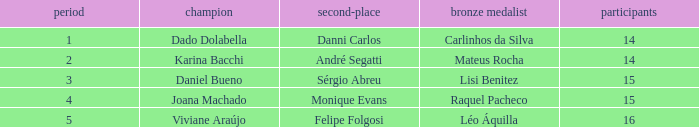How many contestants were there when the runner-up was Sérgio Abreu?  15.0. 